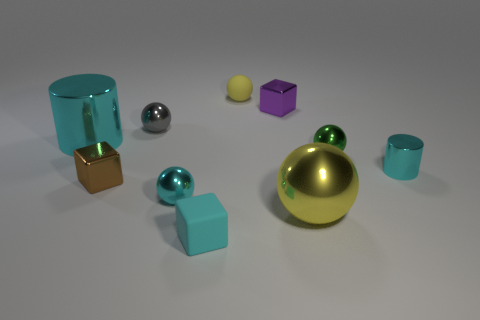Subtract 1 blocks. How many blocks are left? 2 Subtract all rubber cubes. How many cubes are left? 2 Subtract all blue balls. How many purple cylinders are left? 0 Subtract all cyan blocks. How many blocks are left? 2 Subtract 0 green blocks. How many objects are left? 10 Subtract all cylinders. How many objects are left? 8 Subtract all gray cylinders. Subtract all green balls. How many cylinders are left? 2 Subtract all gray objects. Subtract all cyan rubber things. How many objects are left? 8 Add 9 yellow metal things. How many yellow metal things are left? 10 Add 4 tiny green things. How many tiny green things exist? 5 